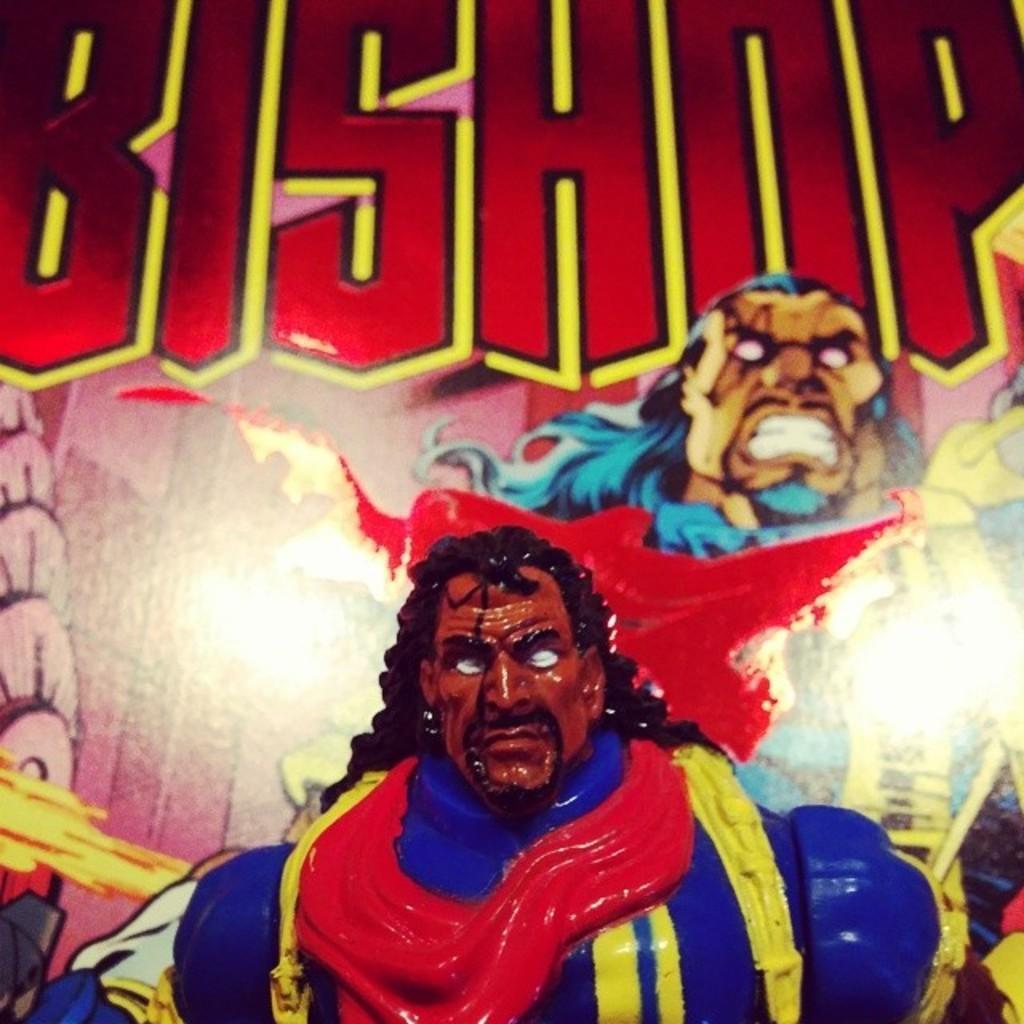Please provide a concise description of this image. In this image I can see a toy. In the background, I can see a picture of a person with some text written on the wall. 